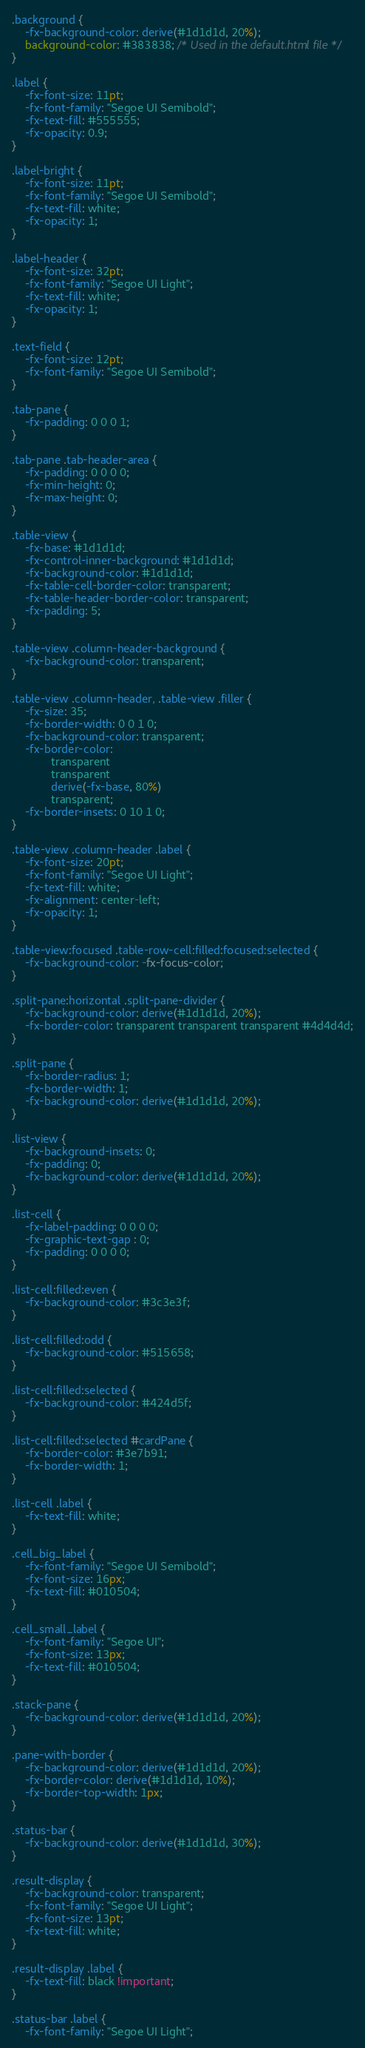Convert code to text. <code><loc_0><loc_0><loc_500><loc_500><_CSS_>.background {
    -fx-background-color: derive(#1d1d1d, 20%);
    background-color: #383838; /* Used in the default.html file */
}

.label {
    -fx-font-size: 11pt;
    -fx-font-family: "Segoe UI Semibold";
    -fx-text-fill: #555555;
    -fx-opacity: 0.9;
}

.label-bright {
    -fx-font-size: 11pt;
    -fx-font-family: "Segoe UI Semibold";
    -fx-text-fill: white;
    -fx-opacity: 1;
}

.label-header {
    -fx-font-size: 32pt;
    -fx-font-family: "Segoe UI Light";
    -fx-text-fill: white;
    -fx-opacity: 1;
}

.text-field {
    -fx-font-size: 12pt;
    -fx-font-family: "Segoe UI Semibold";
}

.tab-pane {
    -fx-padding: 0 0 0 1;
}

.tab-pane .tab-header-area {
    -fx-padding: 0 0 0 0;
    -fx-min-height: 0;
    -fx-max-height: 0;
}

.table-view {
    -fx-base: #1d1d1d;
    -fx-control-inner-background: #1d1d1d;
    -fx-background-color: #1d1d1d;
    -fx-table-cell-border-color: transparent;
    -fx-table-header-border-color: transparent;
    -fx-padding: 5;
}

.table-view .column-header-background {
    -fx-background-color: transparent;
}

.table-view .column-header, .table-view .filler {
    -fx-size: 35;
    -fx-border-width: 0 0 1 0;
    -fx-background-color: transparent;
    -fx-border-color:
            transparent
            transparent
            derive(-fx-base, 80%)
            transparent;
    -fx-border-insets: 0 10 1 0;
}

.table-view .column-header .label {
    -fx-font-size: 20pt;
    -fx-font-family: "Segoe UI Light";
    -fx-text-fill: white;
    -fx-alignment: center-left;
    -fx-opacity: 1;
}

.table-view:focused .table-row-cell:filled:focused:selected {
    -fx-background-color: -fx-focus-color;
}

.split-pane:horizontal .split-pane-divider {
    -fx-background-color: derive(#1d1d1d, 20%);
    -fx-border-color: transparent transparent transparent #4d4d4d;
}

.split-pane {
    -fx-border-radius: 1;
    -fx-border-width: 1;
    -fx-background-color: derive(#1d1d1d, 20%);
}

.list-view {
    -fx-background-insets: 0;
    -fx-padding: 0;
    -fx-background-color: derive(#1d1d1d, 20%);
}

.list-cell {
    -fx-label-padding: 0 0 0 0;
    -fx-graphic-text-gap : 0;
    -fx-padding: 0 0 0 0;
}

.list-cell:filled:even {
    -fx-background-color: #3c3e3f;
}

.list-cell:filled:odd {
    -fx-background-color: #515658;
}

.list-cell:filled:selected {
    -fx-background-color: #424d5f;
}

.list-cell:filled:selected #cardPane {
    -fx-border-color: #3e7b91;
    -fx-border-width: 1;
}

.list-cell .label {
    -fx-text-fill: white;
}

.cell_big_label {
    -fx-font-family: "Segoe UI Semibold";
    -fx-font-size: 16px;
    -fx-text-fill: #010504;
}

.cell_small_label {
    -fx-font-family: "Segoe UI";
    -fx-font-size: 13px;
    -fx-text-fill: #010504;
}

.stack-pane {
    -fx-background-color: derive(#1d1d1d, 20%);
}

.pane-with-border {
    -fx-background-color: derive(#1d1d1d, 20%);
    -fx-border-color: derive(#1d1d1d, 10%);
    -fx-border-top-width: 1px;
}

.status-bar {
    -fx-background-color: derive(#1d1d1d, 30%);
}

.result-display {
    -fx-background-color: transparent;
    -fx-font-family: "Segoe UI Light";
    -fx-font-size: 13pt;
    -fx-text-fill: white;
}

.result-display .label {
    -fx-text-fill: black !important;
}

.status-bar .label {
    -fx-font-family: "Segoe UI Light";</code> 